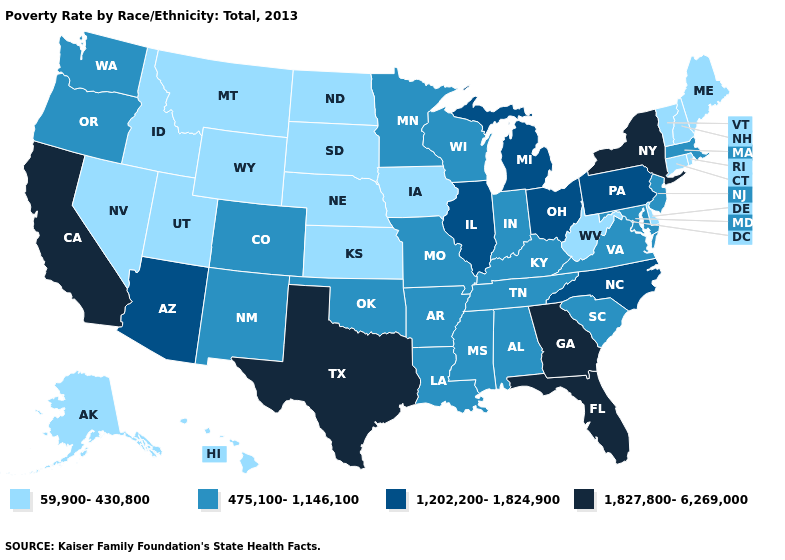Is the legend a continuous bar?
Quick response, please. No. Among the states that border Indiana , which have the lowest value?
Be succinct. Kentucky. What is the value of Louisiana?
Quick response, please. 475,100-1,146,100. What is the value of Alabama?
Give a very brief answer. 475,100-1,146,100. Does Delaware have the lowest value in the South?
Concise answer only. Yes. Name the states that have a value in the range 59,900-430,800?
Give a very brief answer. Alaska, Connecticut, Delaware, Hawaii, Idaho, Iowa, Kansas, Maine, Montana, Nebraska, Nevada, New Hampshire, North Dakota, Rhode Island, South Dakota, Utah, Vermont, West Virginia, Wyoming. Which states hav the highest value in the Northeast?
Give a very brief answer. New York. Does Arizona have the lowest value in the West?
Quick response, please. No. Name the states that have a value in the range 59,900-430,800?
Answer briefly. Alaska, Connecticut, Delaware, Hawaii, Idaho, Iowa, Kansas, Maine, Montana, Nebraska, Nevada, New Hampshire, North Dakota, Rhode Island, South Dakota, Utah, Vermont, West Virginia, Wyoming. What is the highest value in the MidWest ?
Quick response, please. 1,202,200-1,824,900. Does Delaware have the lowest value in the USA?
Short answer required. Yes. Does Wyoming have a lower value than Idaho?
Give a very brief answer. No. Among the states that border Wyoming , which have the highest value?
Short answer required. Colorado. What is the highest value in the Northeast ?
Be succinct. 1,827,800-6,269,000. What is the value of Wyoming?
Be succinct. 59,900-430,800. 